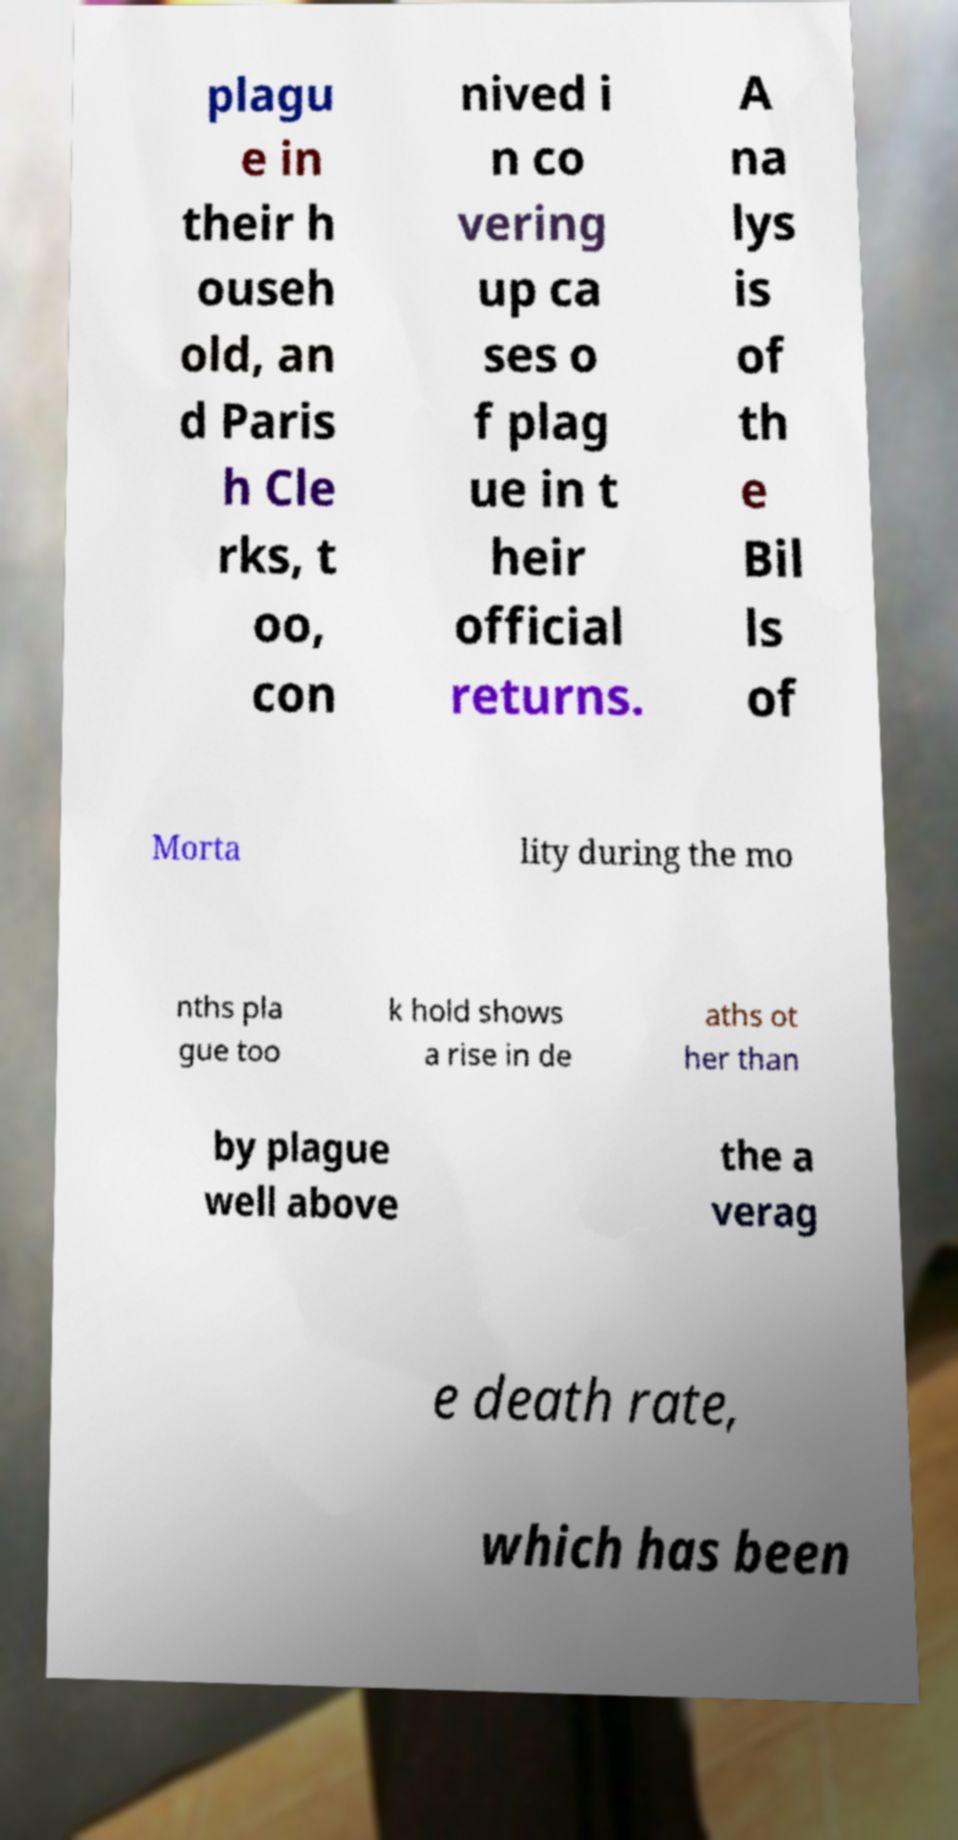There's text embedded in this image that I need extracted. Can you transcribe it verbatim? plagu e in their h ouseh old, an d Paris h Cle rks, t oo, con nived i n co vering up ca ses o f plag ue in t heir official returns. A na lys is of th e Bil ls of Morta lity during the mo nths pla gue too k hold shows a rise in de aths ot her than by plague well above the a verag e death rate, which has been 